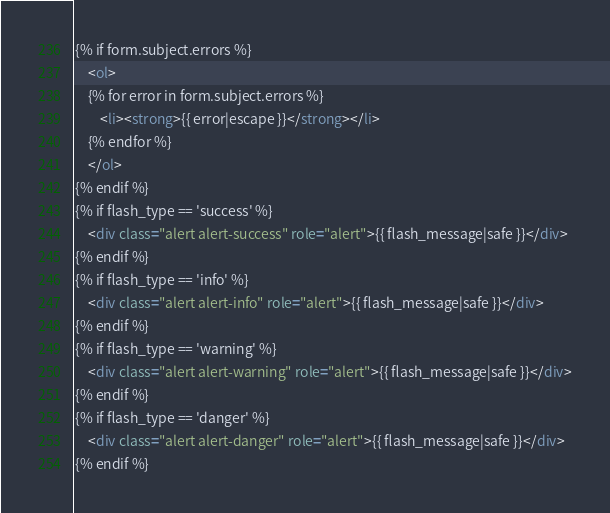Convert code to text. <code><loc_0><loc_0><loc_500><loc_500><_HTML_>{% if form.subject.errors %}
    <ol>
    {% for error in form.subject.errors %}
        <li><strong>{{ error|escape }}</strong></li>
    {% endfor %}
    </ol>
{% endif %}
{% if flash_type == 'success' %}
    <div class="alert alert-success" role="alert">{{ flash_message|safe }}</div>
{% endif %}
{% if flash_type == 'info' %}
    <div class="alert alert-info" role="alert">{{ flash_message|safe }}</div>
{% endif %}
{% if flash_type == 'warning' %}
    <div class="alert alert-warning" role="alert">{{ flash_message|safe }}</div>
{% endif %}
{% if flash_type == 'danger' %}
    <div class="alert alert-danger" role="alert">{{ flash_message|safe }}</div>
{% endif %}</code> 